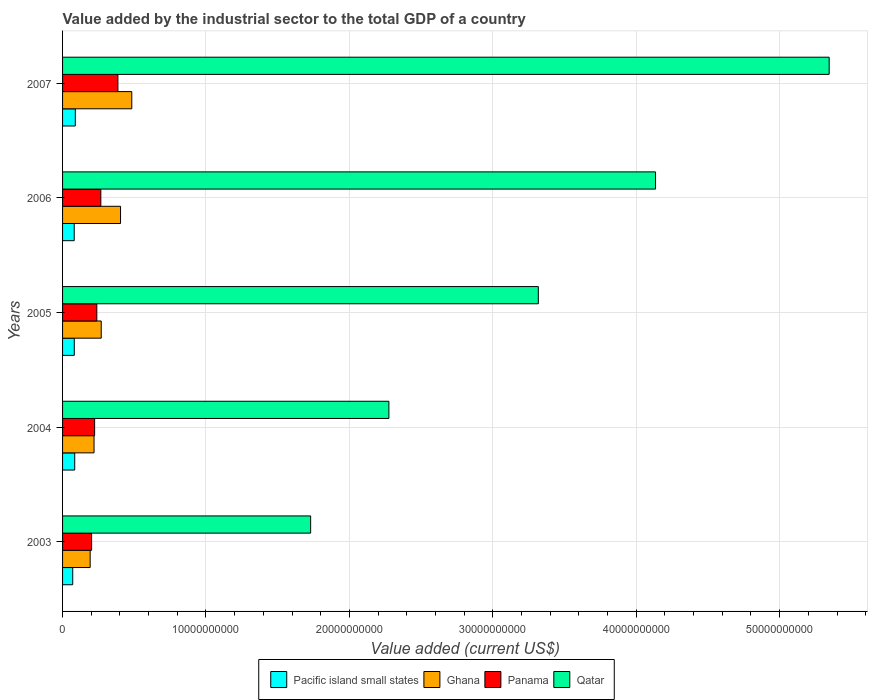What is the label of the 2nd group of bars from the top?
Your answer should be compact. 2006. In how many cases, is the number of bars for a given year not equal to the number of legend labels?
Your response must be concise. 0. What is the value added by the industrial sector to the total GDP in Panama in 2005?
Your answer should be very brief. 2.39e+09. Across all years, what is the maximum value added by the industrial sector to the total GDP in Ghana?
Your response must be concise. 4.83e+09. Across all years, what is the minimum value added by the industrial sector to the total GDP in Pacific island small states?
Ensure brevity in your answer.  7.09e+08. In which year was the value added by the industrial sector to the total GDP in Pacific island small states maximum?
Ensure brevity in your answer.  2007. In which year was the value added by the industrial sector to the total GDP in Ghana minimum?
Provide a succinct answer. 2003. What is the total value added by the industrial sector to the total GDP in Panama in the graph?
Provide a short and direct response. 1.32e+1. What is the difference between the value added by the industrial sector to the total GDP in Pacific island small states in 2003 and that in 2004?
Give a very brief answer. -1.38e+08. What is the difference between the value added by the industrial sector to the total GDP in Qatar in 2004 and the value added by the industrial sector to the total GDP in Panama in 2003?
Make the answer very short. 2.07e+1. What is the average value added by the industrial sector to the total GDP in Qatar per year?
Your response must be concise. 3.36e+1. In the year 2005, what is the difference between the value added by the industrial sector to the total GDP in Ghana and value added by the industrial sector to the total GDP in Qatar?
Your answer should be very brief. -3.05e+1. In how many years, is the value added by the industrial sector to the total GDP in Qatar greater than 14000000000 US$?
Make the answer very short. 5. What is the ratio of the value added by the industrial sector to the total GDP in Qatar in 2004 to that in 2007?
Provide a succinct answer. 0.43. Is the value added by the industrial sector to the total GDP in Qatar in 2003 less than that in 2006?
Give a very brief answer. Yes. Is the difference between the value added by the industrial sector to the total GDP in Ghana in 2005 and 2007 greater than the difference between the value added by the industrial sector to the total GDP in Qatar in 2005 and 2007?
Offer a terse response. Yes. What is the difference between the highest and the second highest value added by the industrial sector to the total GDP in Panama?
Provide a short and direct response. 1.19e+09. What is the difference between the highest and the lowest value added by the industrial sector to the total GDP in Panama?
Give a very brief answer. 1.83e+09. What does the 2nd bar from the top in 2004 represents?
Your answer should be very brief. Panama. What does the 3rd bar from the bottom in 2007 represents?
Give a very brief answer. Panama. Are all the bars in the graph horizontal?
Provide a short and direct response. Yes. Are the values on the major ticks of X-axis written in scientific E-notation?
Make the answer very short. No. Does the graph contain grids?
Your response must be concise. Yes. How are the legend labels stacked?
Give a very brief answer. Horizontal. What is the title of the graph?
Your response must be concise. Value added by the industrial sector to the total GDP of a country. Does "High income: nonOECD" appear as one of the legend labels in the graph?
Provide a short and direct response. No. What is the label or title of the X-axis?
Your answer should be compact. Value added (current US$). What is the label or title of the Y-axis?
Ensure brevity in your answer.  Years. What is the Value added (current US$) of Pacific island small states in 2003?
Offer a terse response. 7.09e+08. What is the Value added (current US$) in Ghana in 2003?
Offer a terse response. 1.92e+09. What is the Value added (current US$) in Panama in 2003?
Offer a very short reply. 2.03e+09. What is the Value added (current US$) of Qatar in 2003?
Your response must be concise. 1.73e+1. What is the Value added (current US$) in Pacific island small states in 2004?
Offer a terse response. 8.47e+08. What is the Value added (current US$) in Ghana in 2004?
Provide a short and direct response. 2.20e+09. What is the Value added (current US$) of Panama in 2004?
Your answer should be compact. 2.24e+09. What is the Value added (current US$) in Qatar in 2004?
Give a very brief answer. 2.28e+1. What is the Value added (current US$) in Pacific island small states in 2005?
Your answer should be compact. 8.17e+08. What is the Value added (current US$) in Ghana in 2005?
Offer a very short reply. 2.70e+09. What is the Value added (current US$) of Panama in 2005?
Your response must be concise. 2.39e+09. What is the Value added (current US$) of Qatar in 2005?
Give a very brief answer. 3.32e+1. What is the Value added (current US$) in Pacific island small states in 2006?
Provide a short and direct response. 8.12e+08. What is the Value added (current US$) in Ghana in 2006?
Make the answer very short. 4.04e+09. What is the Value added (current US$) of Panama in 2006?
Your response must be concise. 2.67e+09. What is the Value added (current US$) in Qatar in 2006?
Keep it short and to the point. 4.13e+1. What is the Value added (current US$) of Pacific island small states in 2007?
Your response must be concise. 8.89e+08. What is the Value added (current US$) of Ghana in 2007?
Ensure brevity in your answer.  4.83e+09. What is the Value added (current US$) of Panama in 2007?
Provide a short and direct response. 3.86e+09. What is the Value added (current US$) of Qatar in 2007?
Provide a succinct answer. 5.35e+1. Across all years, what is the maximum Value added (current US$) of Pacific island small states?
Offer a terse response. 8.89e+08. Across all years, what is the maximum Value added (current US$) of Ghana?
Give a very brief answer. 4.83e+09. Across all years, what is the maximum Value added (current US$) in Panama?
Keep it short and to the point. 3.86e+09. Across all years, what is the maximum Value added (current US$) in Qatar?
Provide a succinct answer. 5.35e+1. Across all years, what is the minimum Value added (current US$) of Pacific island small states?
Ensure brevity in your answer.  7.09e+08. Across all years, what is the minimum Value added (current US$) in Ghana?
Give a very brief answer. 1.92e+09. Across all years, what is the minimum Value added (current US$) in Panama?
Ensure brevity in your answer.  2.03e+09. Across all years, what is the minimum Value added (current US$) of Qatar?
Provide a short and direct response. 1.73e+1. What is the total Value added (current US$) in Pacific island small states in the graph?
Keep it short and to the point. 4.07e+09. What is the total Value added (current US$) in Ghana in the graph?
Offer a very short reply. 1.57e+1. What is the total Value added (current US$) of Panama in the graph?
Give a very brief answer. 1.32e+1. What is the total Value added (current US$) of Qatar in the graph?
Provide a succinct answer. 1.68e+11. What is the difference between the Value added (current US$) of Pacific island small states in 2003 and that in 2004?
Provide a short and direct response. -1.38e+08. What is the difference between the Value added (current US$) in Ghana in 2003 and that in 2004?
Ensure brevity in your answer.  -2.71e+08. What is the difference between the Value added (current US$) of Panama in 2003 and that in 2004?
Give a very brief answer. -2.10e+08. What is the difference between the Value added (current US$) of Qatar in 2003 and that in 2004?
Give a very brief answer. -5.46e+09. What is the difference between the Value added (current US$) of Pacific island small states in 2003 and that in 2005?
Your answer should be compact. -1.08e+08. What is the difference between the Value added (current US$) of Ghana in 2003 and that in 2005?
Give a very brief answer. -7.72e+08. What is the difference between the Value added (current US$) of Panama in 2003 and that in 2005?
Keep it short and to the point. -3.64e+08. What is the difference between the Value added (current US$) of Qatar in 2003 and that in 2005?
Ensure brevity in your answer.  -1.59e+1. What is the difference between the Value added (current US$) of Pacific island small states in 2003 and that in 2006?
Offer a terse response. -1.04e+08. What is the difference between the Value added (current US$) of Ghana in 2003 and that in 2006?
Offer a very short reply. -2.12e+09. What is the difference between the Value added (current US$) of Panama in 2003 and that in 2006?
Provide a succinct answer. -6.42e+08. What is the difference between the Value added (current US$) in Qatar in 2003 and that in 2006?
Your answer should be very brief. -2.40e+1. What is the difference between the Value added (current US$) of Pacific island small states in 2003 and that in 2007?
Keep it short and to the point. -1.80e+08. What is the difference between the Value added (current US$) in Ghana in 2003 and that in 2007?
Make the answer very short. -2.90e+09. What is the difference between the Value added (current US$) in Panama in 2003 and that in 2007?
Make the answer very short. -1.83e+09. What is the difference between the Value added (current US$) of Qatar in 2003 and that in 2007?
Make the answer very short. -3.62e+1. What is the difference between the Value added (current US$) in Pacific island small states in 2004 and that in 2005?
Keep it short and to the point. 3.03e+07. What is the difference between the Value added (current US$) in Ghana in 2004 and that in 2005?
Your answer should be very brief. -5.01e+08. What is the difference between the Value added (current US$) of Panama in 2004 and that in 2005?
Your answer should be very brief. -1.53e+08. What is the difference between the Value added (current US$) in Qatar in 2004 and that in 2005?
Your response must be concise. -1.04e+1. What is the difference between the Value added (current US$) of Pacific island small states in 2004 and that in 2006?
Ensure brevity in your answer.  3.47e+07. What is the difference between the Value added (current US$) of Ghana in 2004 and that in 2006?
Offer a very short reply. -1.85e+09. What is the difference between the Value added (current US$) of Panama in 2004 and that in 2006?
Provide a short and direct response. -4.32e+08. What is the difference between the Value added (current US$) in Qatar in 2004 and that in 2006?
Keep it short and to the point. -1.86e+1. What is the difference between the Value added (current US$) in Pacific island small states in 2004 and that in 2007?
Provide a succinct answer. -4.17e+07. What is the difference between the Value added (current US$) in Ghana in 2004 and that in 2007?
Offer a terse response. -2.63e+09. What is the difference between the Value added (current US$) in Panama in 2004 and that in 2007?
Offer a terse response. -1.62e+09. What is the difference between the Value added (current US$) of Qatar in 2004 and that in 2007?
Your answer should be compact. -3.07e+1. What is the difference between the Value added (current US$) in Pacific island small states in 2005 and that in 2006?
Your response must be concise. 4.37e+06. What is the difference between the Value added (current US$) in Ghana in 2005 and that in 2006?
Ensure brevity in your answer.  -1.35e+09. What is the difference between the Value added (current US$) of Panama in 2005 and that in 2006?
Your answer should be compact. -2.79e+08. What is the difference between the Value added (current US$) of Qatar in 2005 and that in 2006?
Give a very brief answer. -8.17e+09. What is the difference between the Value added (current US$) of Pacific island small states in 2005 and that in 2007?
Offer a terse response. -7.21e+07. What is the difference between the Value added (current US$) in Ghana in 2005 and that in 2007?
Your answer should be compact. -2.13e+09. What is the difference between the Value added (current US$) in Panama in 2005 and that in 2007?
Provide a succinct answer. -1.47e+09. What is the difference between the Value added (current US$) of Qatar in 2005 and that in 2007?
Your response must be concise. -2.03e+1. What is the difference between the Value added (current US$) in Pacific island small states in 2006 and that in 2007?
Your response must be concise. -7.64e+07. What is the difference between the Value added (current US$) in Ghana in 2006 and that in 2007?
Ensure brevity in your answer.  -7.84e+08. What is the difference between the Value added (current US$) of Panama in 2006 and that in 2007?
Give a very brief answer. -1.19e+09. What is the difference between the Value added (current US$) of Qatar in 2006 and that in 2007?
Make the answer very short. -1.21e+1. What is the difference between the Value added (current US$) of Pacific island small states in 2003 and the Value added (current US$) of Ghana in 2004?
Your response must be concise. -1.49e+09. What is the difference between the Value added (current US$) in Pacific island small states in 2003 and the Value added (current US$) in Panama in 2004?
Ensure brevity in your answer.  -1.53e+09. What is the difference between the Value added (current US$) in Pacific island small states in 2003 and the Value added (current US$) in Qatar in 2004?
Your answer should be very brief. -2.20e+1. What is the difference between the Value added (current US$) in Ghana in 2003 and the Value added (current US$) in Panama in 2004?
Offer a terse response. -3.12e+08. What is the difference between the Value added (current US$) in Ghana in 2003 and the Value added (current US$) in Qatar in 2004?
Make the answer very short. -2.08e+1. What is the difference between the Value added (current US$) of Panama in 2003 and the Value added (current US$) of Qatar in 2004?
Your response must be concise. -2.07e+1. What is the difference between the Value added (current US$) in Pacific island small states in 2003 and the Value added (current US$) in Ghana in 2005?
Give a very brief answer. -1.99e+09. What is the difference between the Value added (current US$) in Pacific island small states in 2003 and the Value added (current US$) in Panama in 2005?
Provide a short and direct response. -1.68e+09. What is the difference between the Value added (current US$) in Pacific island small states in 2003 and the Value added (current US$) in Qatar in 2005?
Ensure brevity in your answer.  -3.25e+1. What is the difference between the Value added (current US$) in Ghana in 2003 and the Value added (current US$) in Panama in 2005?
Your response must be concise. -4.65e+08. What is the difference between the Value added (current US$) of Ghana in 2003 and the Value added (current US$) of Qatar in 2005?
Offer a terse response. -3.12e+1. What is the difference between the Value added (current US$) in Panama in 2003 and the Value added (current US$) in Qatar in 2005?
Ensure brevity in your answer.  -3.11e+1. What is the difference between the Value added (current US$) of Pacific island small states in 2003 and the Value added (current US$) of Ghana in 2006?
Offer a terse response. -3.33e+09. What is the difference between the Value added (current US$) in Pacific island small states in 2003 and the Value added (current US$) in Panama in 2006?
Ensure brevity in your answer.  -1.96e+09. What is the difference between the Value added (current US$) of Pacific island small states in 2003 and the Value added (current US$) of Qatar in 2006?
Ensure brevity in your answer.  -4.06e+1. What is the difference between the Value added (current US$) of Ghana in 2003 and the Value added (current US$) of Panama in 2006?
Your response must be concise. -7.44e+08. What is the difference between the Value added (current US$) of Ghana in 2003 and the Value added (current US$) of Qatar in 2006?
Your response must be concise. -3.94e+1. What is the difference between the Value added (current US$) of Panama in 2003 and the Value added (current US$) of Qatar in 2006?
Your answer should be compact. -3.93e+1. What is the difference between the Value added (current US$) in Pacific island small states in 2003 and the Value added (current US$) in Ghana in 2007?
Your answer should be compact. -4.12e+09. What is the difference between the Value added (current US$) of Pacific island small states in 2003 and the Value added (current US$) of Panama in 2007?
Offer a terse response. -3.15e+09. What is the difference between the Value added (current US$) in Pacific island small states in 2003 and the Value added (current US$) in Qatar in 2007?
Provide a short and direct response. -5.27e+1. What is the difference between the Value added (current US$) of Ghana in 2003 and the Value added (current US$) of Panama in 2007?
Give a very brief answer. -1.93e+09. What is the difference between the Value added (current US$) of Ghana in 2003 and the Value added (current US$) of Qatar in 2007?
Ensure brevity in your answer.  -5.15e+1. What is the difference between the Value added (current US$) in Panama in 2003 and the Value added (current US$) in Qatar in 2007?
Provide a succinct answer. -5.14e+1. What is the difference between the Value added (current US$) of Pacific island small states in 2004 and the Value added (current US$) of Ghana in 2005?
Make the answer very short. -1.85e+09. What is the difference between the Value added (current US$) of Pacific island small states in 2004 and the Value added (current US$) of Panama in 2005?
Provide a succinct answer. -1.54e+09. What is the difference between the Value added (current US$) in Pacific island small states in 2004 and the Value added (current US$) in Qatar in 2005?
Offer a terse response. -3.23e+1. What is the difference between the Value added (current US$) of Ghana in 2004 and the Value added (current US$) of Panama in 2005?
Keep it short and to the point. -1.94e+08. What is the difference between the Value added (current US$) of Ghana in 2004 and the Value added (current US$) of Qatar in 2005?
Offer a terse response. -3.10e+1. What is the difference between the Value added (current US$) of Panama in 2004 and the Value added (current US$) of Qatar in 2005?
Provide a succinct answer. -3.09e+1. What is the difference between the Value added (current US$) in Pacific island small states in 2004 and the Value added (current US$) in Ghana in 2006?
Give a very brief answer. -3.19e+09. What is the difference between the Value added (current US$) in Pacific island small states in 2004 and the Value added (current US$) in Panama in 2006?
Provide a short and direct response. -1.82e+09. What is the difference between the Value added (current US$) in Pacific island small states in 2004 and the Value added (current US$) in Qatar in 2006?
Your response must be concise. -4.05e+1. What is the difference between the Value added (current US$) in Ghana in 2004 and the Value added (current US$) in Panama in 2006?
Give a very brief answer. -4.73e+08. What is the difference between the Value added (current US$) in Ghana in 2004 and the Value added (current US$) in Qatar in 2006?
Your answer should be compact. -3.92e+1. What is the difference between the Value added (current US$) of Panama in 2004 and the Value added (current US$) of Qatar in 2006?
Ensure brevity in your answer.  -3.91e+1. What is the difference between the Value added (current US$) in Pacific island small states in 2004 and the Value added (current US$) in Ghana in 2007?
Offer a very short reply. -3.98e+09. What is the difference between the Value added (current US$) in Pacific island small states in 2004 and the Value added (current US$) in Panama in 2007?
Offer a terse response. -3.01e+09. What is the difference between the Value added (current US$) in Pacific island small states in 2004 and the Value added (current US$) in Qatar in 2007?
Provide a succinct answer. -5.26e+1. What is the difference between the Value added (current US$) in Ghana in 2004 and the Value added (current US$) in Panama in 2007?
Your response must be concise. -1.66e+09. What is the difference between the Value added (current US$) of Ghana in 2004 and the Value added (current US$) of Qatar in 2007?
Make the answer very short. -5.13e+1. What is the difference between the Value added (current US$) in Panama in 2004 and the Value added (current US$) in Qatar in 2007?
Offer a terse response. -5.12e+1. What is the difference between the Value added (current US$) of Pacific island small states in 2005 and the Value added (current US$) of Ghana in 2006?
Your response must be concise. -3.22e+09. What is the difference between the Value added (current US$) in Pacific island small states in 2005 and the Value added (current US$) in Panama in 2006?
Provide a short and direct response. -1.85e+09. What is the difference between the Value added (current US$) in Pacific island small states in 2005 and the Value added (current US$) in Qatar in 2006?
Offer a terse response. -4.05e+1. What is the difference between the Value added (current US$) in Ghana in 2005 and the Value added (current US$) in Panama in 2006?
Your answer should be very brief. 2.86e+07. What is the difference between the Value added (current US$) of Ghana in 2005 and the Value added (current US$) of Qatar in 2006?
Keep it short and to the point. -3.87e+1. What is the difference between the Value added (current US$) of Panama in 2005 and the Value added (current US$) of Qatar in 2006?
Make the answer very short. -3.90e+1. What is the difference between the Value added (current US$) in Pacific island small states in 2005 and the Value added (current US$) in Ghana in 2007?
Provide a succinct answer. -4.01e+09. What is the difference between the Value added (current US$) of Pacific island small states in 2005 and the Value added (current US$) of Panama in 2007?
Your answer should be very brief. -3.04e+09. What is the difference between the Value added (current US$) of Pacific island small states in 2005 and the Value added (current US$) of Qatar in 2007?
Provide a short and direct response. -5.26e+1. What is the difference between the Value added (current US$) in Ghana in 2005 and the Value added (current US$) in Panama in 2007?
Your answer should be very brief. -1.16e+09. What is the difference between the Value added (current US$) in Ghana in 2005 and the Value added (current US$) in Qatar in 2007?
Your response must be concise. -5.08e+1. What is the difference between the Value added (current US$) in Panama in 2005 and the Value added (current US$) in Qatar in 2007?
Ensure brevity in your answer.  -5.11e+1. What is the difference between the Value added (current US$) in Pacific island small states in 2006 and the Value added (current US$) in Ghana in 2007?
Ensure brevity in your answer.  -4.01e+09. What is the difference between the Value added (current US$) of Pacific island small states in 2006 and the Value added (current US$) of Panama in 2007?
Your answer should be compact. -3.05e+09. What is the difference between the Value added (current US$) of Pacific island small states in 2006 and the Value added (current US$) of Qatar in 2007?
Offer a terse response. -5.26e+1. What is the difference between the Value added (current US$) of Ghana in 2006 and the Value added (current US$) of Panama in 2007?
Give a very brief answer. 1.83e+08. What is the difference between the Value added (current US$) in Ghana in 2006 and the Value added (current US$) in Qatar in 2007?
Make the answer very short. -4.94e+1. What is the difference between the Value added (current US$) of Panama in 2006 and the Value added (current US$) of Qatar in 2007?
Ensure brevity in your answer.  -5.08e+1. What is the average Value added (current US$) in Pacific island small states per year?
Ensure brevity in your answer.  8.15e+08. What is the average Value added (current US$) in Ghana per year?
Your answer should be very brief. 3.14e+09. What is the average Value added (current US$) in Panama per year?
Provide a short and direct response. 2.64e+09. What is the average Value added (current US$) in Qatar per year?
Provide a succinct answer. 3.36e+1. In the year 2003, what is the difference between the Value added (current US$) in Pacific island small states and Value added (current US$) in Ghana?
Make the answer very short. -1.22e+09. In the year 2003, what is the difference between the Value added (current US$) of Pacific island small states and Value added (current US$) of Panama?
Offer a terse response. -1.32e+09. In the year 2003, what is the difference between the Value added (current US$) of Pacific island small states and Value added (current US$) of Qatar?
Offer a terse response. -1.66e+1. In the year 2003, what is the difference between the Value added (current US$) of Ghana and Value added (current US$) of Panama?
Provide a short and direct response. -1.01e+08. In the year 2003, what is the difference between the Value added (current US$) in Ghana and Value added (current US$) in Qatar?
Offer a terse response. -1.54e+1. In the year 2003, what is the difference between the Value added (current US$) in Panama and Value added (current US$) in Qatar?
Offer a terse response. -1.53e+1. In the year 2004, what is the difference between the Value added (current US$) in Pacific island small states and Value added (current US$) in Ghana?
Keep it short and to the point. -1.35e+09. In the year 2004, what is the difference between the Value added (current US$) in Pacific island small states and Value added (current US$) in Panama?
Your answer should be compact. -1.39e+09. In the year 2004, what is the difference between the Value added (current US$) of Pacific island small states and Value added (current US$) of Qatar?
Your response must be concise. -2.19e+1. In the year 2004, what is the difference between the Value added (current US$) of Ghana and Value added (current US$) of Panama?
Give a very brief answer. -4.05e+07. In the year 2004, what is the difference between the Value added (current US$) in Ghana and Value added (current US$) in Qatar?
Ensure brevity in your answer.  -2.06e+1. In the year 2004, what is the difference between the Value added (current US$) of Panama and Value added (current US$) of Qatar?
Your answer should be very brief. -2.05e+1. In the year 2005, what is the difference between the Value added (current US$) in Pacific island small states and Value added (current US$) in Ghana?
Your response must be concise. -1.88e+09. In the year 2005, what is the difference between the Value added (current US$) in Pacific island small states and Value added (current US$) in Panama?
Ensure brevity in your answer.  -1.57e+09. In the year 2005, what is the difference between the Value added (current US$) in Pacific island small states and Value added (current US$) in Qatar?
Ensure brevity in your answer.  -3.24e+1. In the year 2005, what is the difference between the Value added (current US$) of Ghana and Value added (current US$) of Panama?
Offer a terse response. 3.07e+08. In the year 2005, what is the difference between the Value added (current US$) of Ghana and Value added (current US$) of Qatar?
Your answer should be very brief. -3.05e+1. In the year 2005, what is the difference between the Value added (current US$) in Panama and Value added (current US$) in Qatar?
Provide a short and direct response. -3.08e+1. In the year 2006, what is the difference between the Value added (current US$) in Pacific island small states and Value added (current US$) in Ghana?
Give a very brief answer. -3.23e+09. In the year 2006, what is the difference between the Value added (current US$) in Pacific island small states and Value added (current US$) in Panama?
Offer a very short reply. -1.86e+09. In the year 2006, what is the difference between the Value added (current US$) of Pacific island small states and Value added (current US$) of Qatar?
Keep it short and to the point. -4.05e+1. In the year 2006, what is the difference between the Value added (current US$) in Ghana and Value added (current US$) in Panama?
Give a very brief answer. 1.37e+09. In the year 2006, what is the difference between the Value added (current US$) in Ghana and Value added (current US$) in Qatar?
Offer a very short reply. -3.73e+1. In the year 2006, what is the difference between the Value added (current US$) of Panama and Value added (current US$) of Qatar?
Your response must be concise. -3.87e+1. In the year 2007, what is the difference between the Value added (current US$) of Pacific island small states and Value added (current US$) of Ghana?
Provide a short and direct response. -3.94e+09. In the year 2007, what is the difference between the Value added (current US$) of Pacific island small states and Value added (current US$) of Panama?
Provide a short and direct response. -2.97e+09. In the year 2007, what is the difference between the Value added (current US$) in Pacific island small states and Value added (current US$) in Qatar?
Give a very brief answer. -5.26e+1. In the year 2007, what is the difference between the Value added (current US$) in Ghana and Value added (current US$) in Panama?
Keep it short and to the point. 9.68e+08. In the year 2007, what is the difference between the Value added (current US$) of Ghana and Value added (current US$) of Qatar?
Your answer should be very brief. -4.86e+1. In the year 2007, what is the difference between the Value added (current US$) of Panama and Value added (current US$) of Qatar?
Offer a very short reply. -4.96e+1. What is the ratio of the Value added (current US$) of Pacific island small states in 2003 to that in 2004?
Give a very brief answer. 0.84. What is the ratio of the Value added (current US$) of Ghana in 2003 to that in 2004?
Your response must be concise. 0.88. What is the ratio of the Value added (current US$) in Panama in 2003 to that in 2004?
Your response must be concise. 0.91. What is the ratio of the Value added (current US$) in Qatar in 2003 to that in 2004?
Your answer should be very brief. 0.76. What is the ratio of the Value added (current US$) in Pacific island small states in 2003 to that in 2005?
Provide a short and direct response. 0.87. What is the ratio of the Value added (current US$) of Ghana in 2003 to that in 2005?
Ensure brevity in your answer.  0.71. What is the ratio of the Value added (current US$) of Panama in 2003 to that in 2005?
Offer a terse response. 0.85. What is the ratio of the Value added (current US$) of Qatar in 2003 to that in 2005?
Keep it short and to the point. 0.52. What is the ratio of the Value added (current US$) in Pacific island small states in 2003 to that in 2006?
Your answer should be compact. 0.87. What is the ratio of the Value added (current US$) in Ghana in 2003 to that in 2006?
Your answer should be compact. 0.48. What is the ratio of the Value added (current US$) of Panama in 2003 to that in 2006?
Provide a succinct answer. 0.76. What is the ratio of the Value added (current US$) in Qatar in 2003 to that in 2006?
Your response must be concise. 0.42. What is the ratio of the Value added (current US$) in Pacific island small states in 2003 to that in 2007?
Offer a very short reply. 0.8. What is the ratio of the Value added (current US$) in Ghana in 2003 to that in 2007?
Your answer should be very brief. 0.4. What is the ratio of the Value added (current US$) of Panama in 2003 to that in 2007?
Provide a succinct answer. 0.52. What is the ratio of the Value added (current US$) in Qatar in 2003 to that in 2007?
Offer a very short reply. 0.32. What is the ratio of the Value added (current US$) of Pacific island small states in 2004 to that in 2005?
Your response must be concise. 1.04. What is the ratio of the Value added (current US$) of Ghana in 2004 to that in 2005?
Provide a short and direct response. 0.81. What is the ratio of the Value added (current US$) in Panama in 2004 to that in 2005?
Give a very brief answer. 0.94. What is the ratio of the Value added (current US$) in Qatar in 2004 to that in 2005?
Make the answer very short. 0.69. What is the ratio of the Value added (current US$) in Pacific island small states in 2004 to that in 2006?
Ensure brevity in your answer.  1.04. What is the ratio of the Value added (current US$) of Ghana in 2004 to that in 2006?
Your response must be concise. 0.54. What is the ratio of the Value added (current US$) in Panama in 2004 to that in 2006?
Make the answer very short. 0.84. What is the ratio of the Value added (current US$) of Qatar in 2004 to that in 2006?
Your answer should be very brief. 0.55. What is the ratio of the Value added (current US$) in Pacific island small states in 2004 to that in 2007?
Make the answer very short. 0.95. What is the ratio of the Value added (current US$) of Ghana in 2004 to that in 2007?
Give a very brief answer. 0.45. What is the ratio of the Value added (current US$) in Panama in 2004 to that in 2007?
Provide a succinct answer. 0.58. What is the ratio of the Value added (current US$) of Qatar in 2004 to that in 2007?
Your response must be concise. 0.43. What is the ratio of the Value added (current US$) in Pacific island small states in 2005 to that in 2006?
Provide a short and direct response. 1.01. What is the ratio of the Value added (current US$) in Ghana in 2005 to that in 2006?
Provide a succinct answer. 0.67. What is the ratio of the Value added (current US$) of Panama in 2005 to that in 2006?
Provide a short and direct response. 0.9. What is the ratio of the Value added (current US$) of Qatar in 2005 to that in 2006?
Keep it short and to the point. 0.8. What is the ratio of the Value added (current US$) of Pacific island small states in 2005 to that in 2007?
Provide a short and direct response. 0.92. What is the ratio of the Value added (current US$) of Ghana in 2005 to that in 2007?
Your answer should be very brief. 0.56. What is the ratio of the Value added (current US$) in Panama in 2005 to that in 2007?
Provide a succinct answer. 0.62. What is the ratio of the Value added (current US$) of Qatar in 2005 to that in 2007?
Your response must be concise. 0.62. What is the ratio of the Value added (current US$) of Pacific island small states in 2006 to that in 2007?
Give a very brief answer. 0.91. What is the ratio of the Value added (current US$) of Ghana in 2006 to that in 2007?
Your answer should be compact. 0.84. What is the ratio of the Value added (current US$) of Panama in 2006 to that in 2007?
Offer a terse response. 0.69. What is the ratio of the Value added (current US$) of Qatar in 2006 to that in 2007?
Your answer should be compact. 0.77. What is the difference between the highest and the second highest Value added (current US$) in Pacific island small states?
Keep it short and to the point. 4.17e+07. What is the difference between the highest and the second highest Value added (current US$) in Ghana?
Give a very brief answer. 7.84e+08. What is the difference between the highest and the second highest Value added (current US$) of Panama?
Keep it short and to the point. 1.19e+09. What is the difference between the highest and the second highest Value added (current US$) in Qatar?
Offer a terse response. 1.21e+1. What is the difference between the highest and the lowest Value added (current US$) of Pacific island small states?
Offer a very short reply. 1.80e+08. What is the difference between the highest and the lowest Value added (current US$) of Ghana?
Give a very brief answer. 2.90e+09. What is the difference between the highest and the lowest Value added (current US$) of Panama?
Keep it short and to the point. 1.83e+09. What is the difference between the highest and the lowest Value added (current US$) in Qatar?
Your answer should be compact. 3.62e+1. 